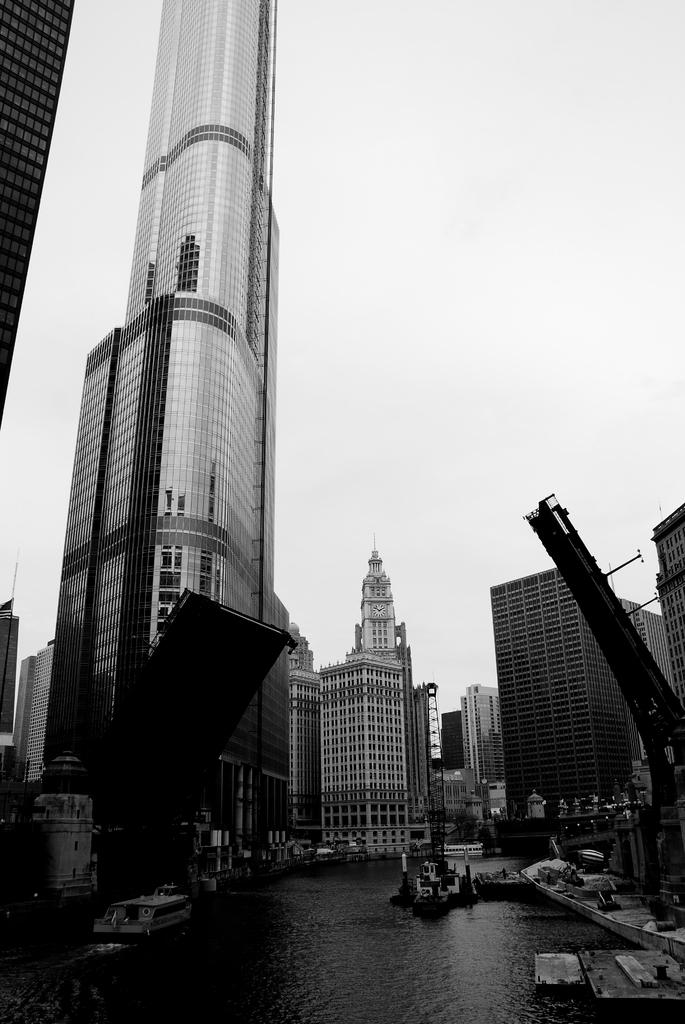What is the main feature in the center of the image? There is water in the center of the image. What can be seen on either side of the water? There are buildings on both sides of the water. What is visible in the background of the image? The sky is visible in the background of the image. What type of transportation is present in the image? There are vehicles on the road in the image. What is the purpose of the airport in the image? There is no airport present in the image; it features water, buildings, and vehicles on the road. 